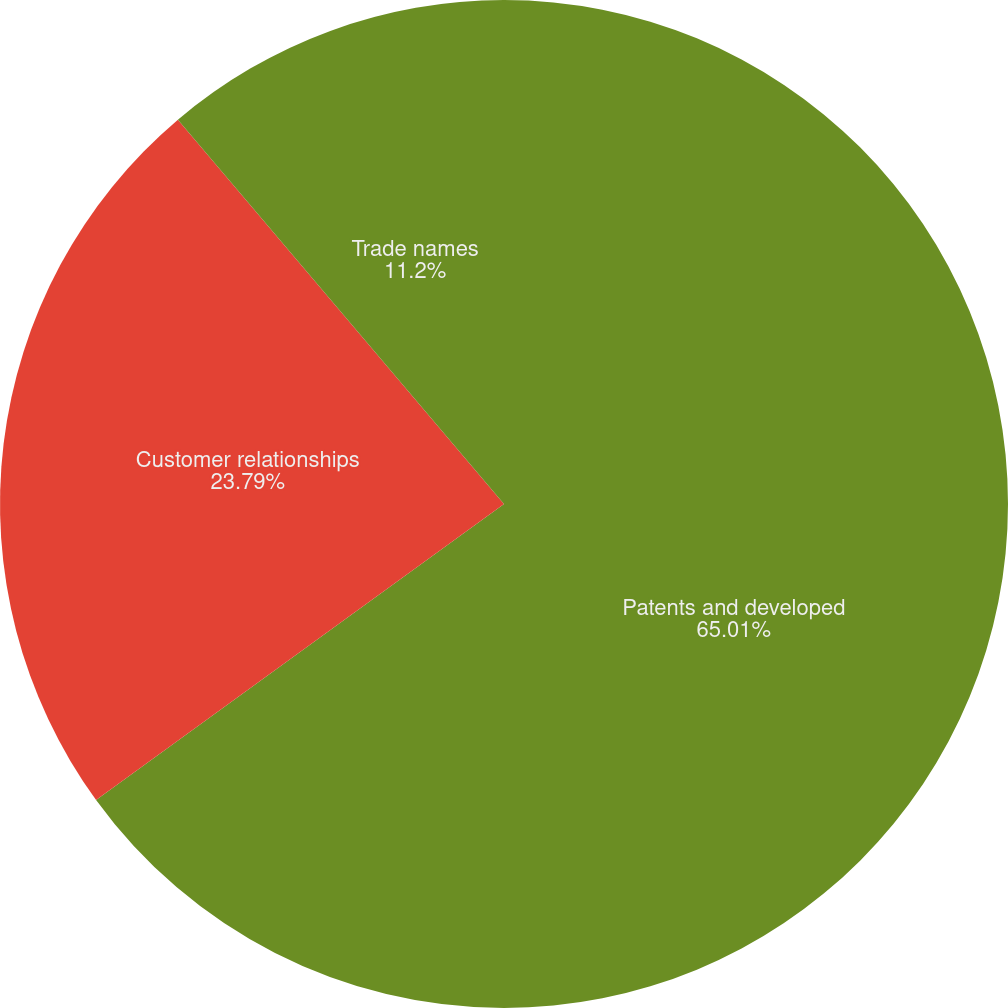Convert chart to OTSL. <chart><loc_0><loc_0><loc_500><loc_500><pie_chart><fcel>Patents and developed<fcel>Customer relationships<fcel>Trade names<nl><fcel>65.01%<fcel>23.79%<fcel>11.2%<nl></chart> 